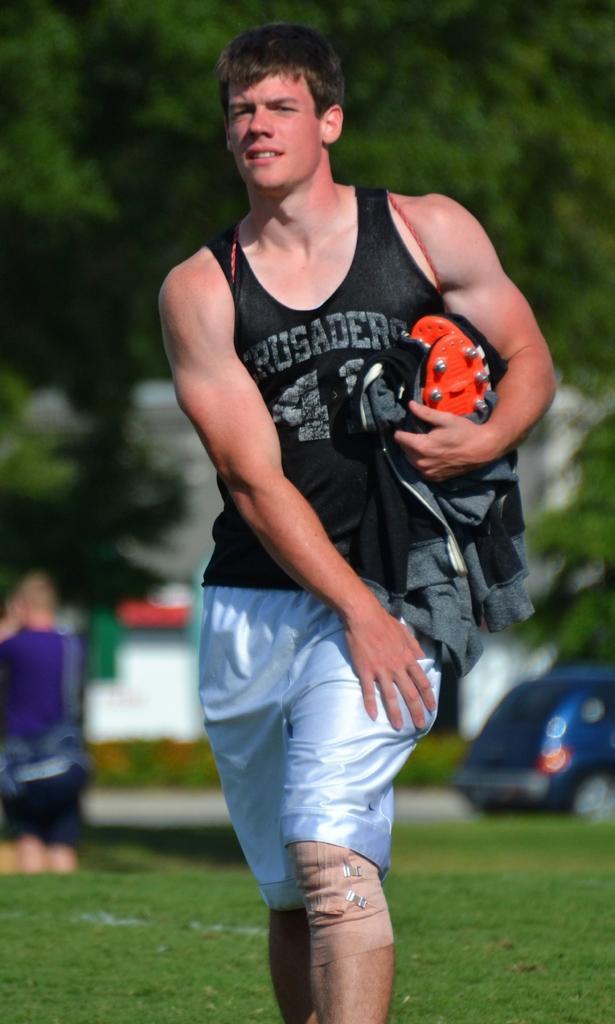In one or two sentences, can you explain what this image depicts? In the center of the image, we can see a man holding coat and some other object in his hand. In the background, there is a vehicle and some people and there are trees. 